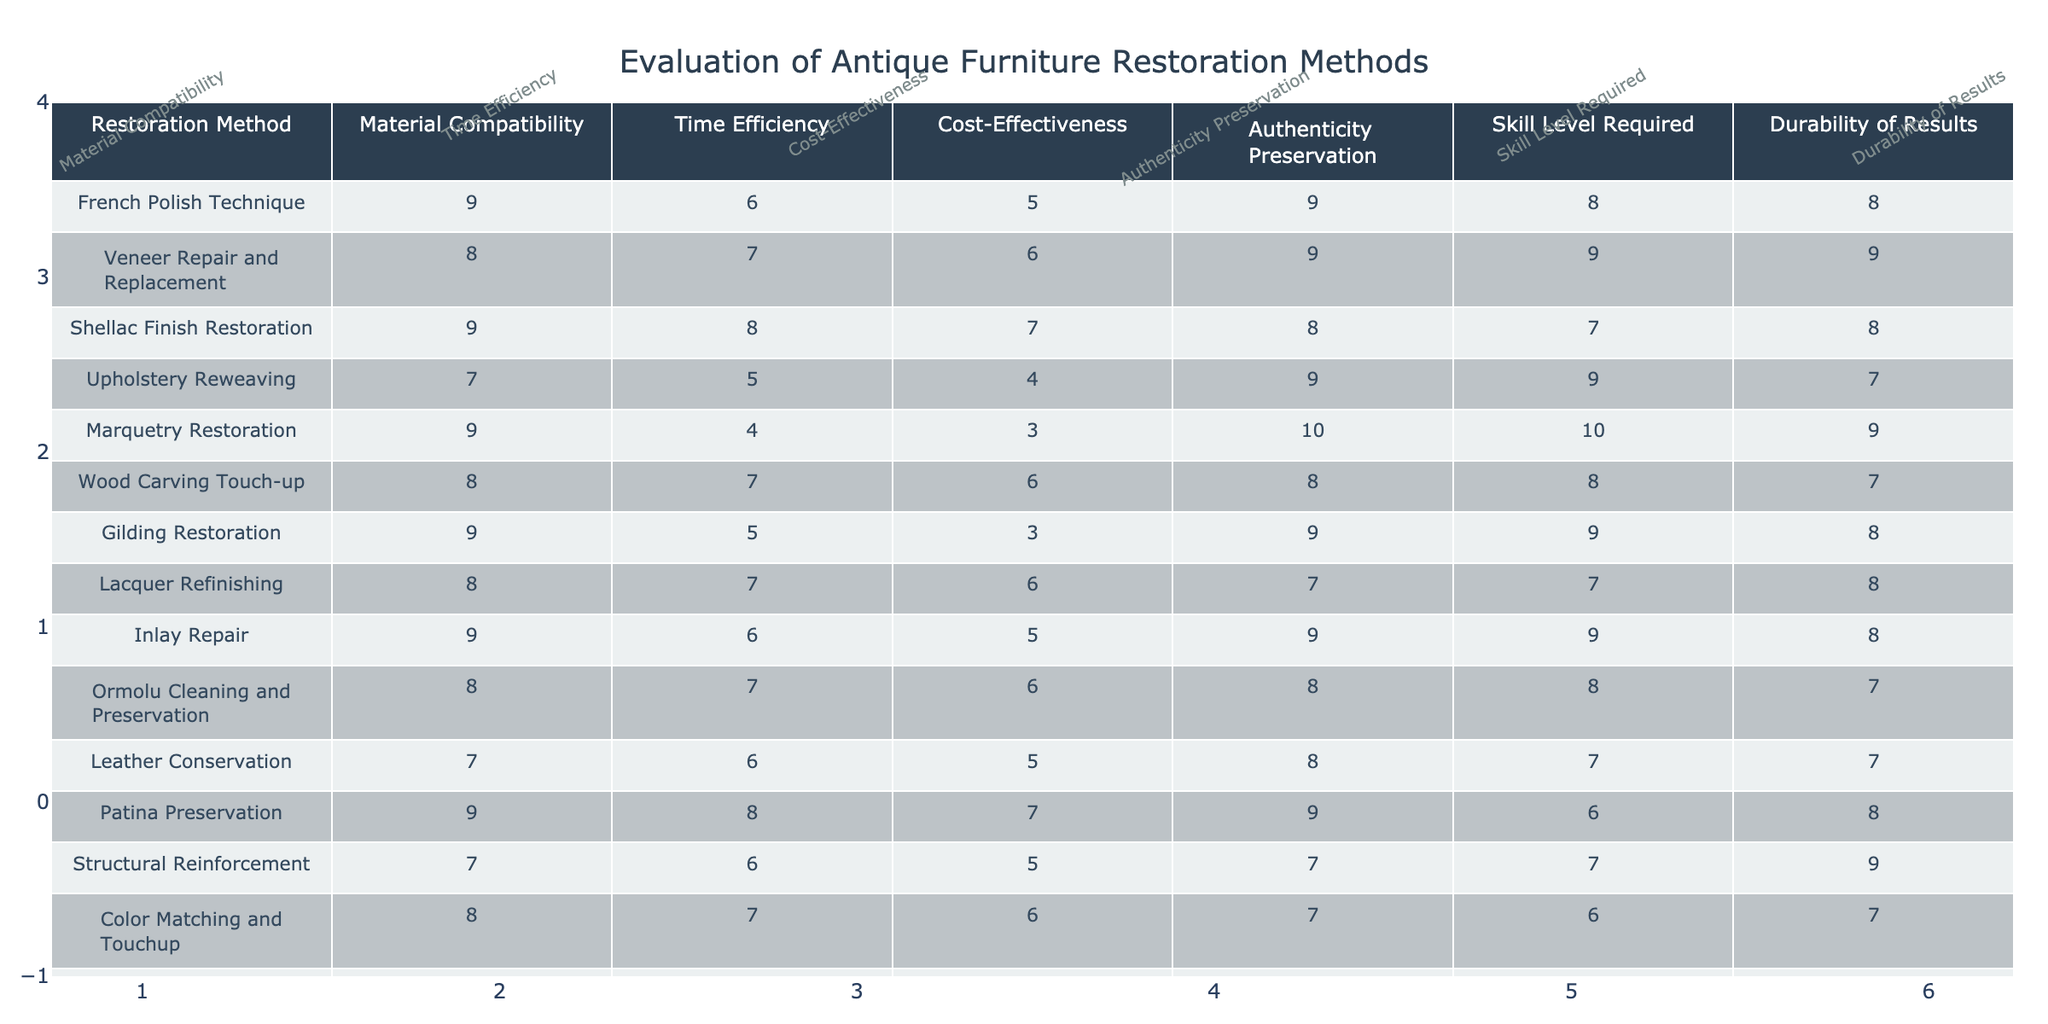What is the highest rating for authenticity preservation among the restoration methods? The restoration method with the highest rating for authenticity preservation is Marquetry Restoration, which has a score of 10.
Answer: 10 Which restoration method has the lowest time efficiency rating? By examining the time efficiency ratings, we see that Marquetry Restoration has the lowest score of 4.
Answer: 4 Is the Skill Level Required rating higher for Veneer Repair and Replacement compared to Upholstery Reweaving? Veneer Repair and Replacement has a skill level required rating of 9, while Upholstery Reweaving has a rating of 9. Since both are equal, the answer is no.
Answer: No What is the average cost-effectiveness rating for all restoration methods? To find the average cost-effectiveness rating, we add all the ratings (5 + 6 + 7 + 4 + 3 + 6 + 3 + 6 + 5 + 6 + 5 + 5 + 6 + 7) = 75. We have 14 methods, so 75/14 ≈ 5.36.
Answer: Approximately 5.36 Which restoration method balances high skill level required and durability of results? If we compare the ratings, both Veneer Repair and Replacement and Marquetry Restoration have high skill levels (9 and 10 respectively). However, Veneer Repair and Replacement has high durability rating (9) compared to Marquetry Restoration (9). Thus, Veneer Repair and Replacement offers a better balance.
Answer: Veneer Repair and Replacement What is the difference in ratings for material compatibility between the most and least compatible restoration methods? The most compatible method is French Polish Technique with a rating of 9, and the least is Upholstery Reweaving, with a rating of 7. The difference is 9 - 7 = 2.
Answer: 2 Is the durability of results for Gilding Restoration equal to that of Color Matching and Touchup? Gilding Restoration has a durability rating of 8, whereas Color Matching and Touchup has a rating of 7. Since they are not equal, the answer is no.
Answer: No Which restoration method has the best combination of high durability and high authenticity preservation? Evaluating the methods, Marquetry Restoration has the best combination with a durability rating of 9 and an authenticity preservation rating of 10.
Answer: Marquetry Restoration Which restoration methods have both a skill level required rating and authenticity preservation higher than 8? From reviewing the table, the methods that satisfy this criteria are French Polish Technique, Veneer Repair and Replacement, Marquetry Restoration, and Inlay Repair, with their respective skill level and authenticity ratings.
Answer: Four methods 